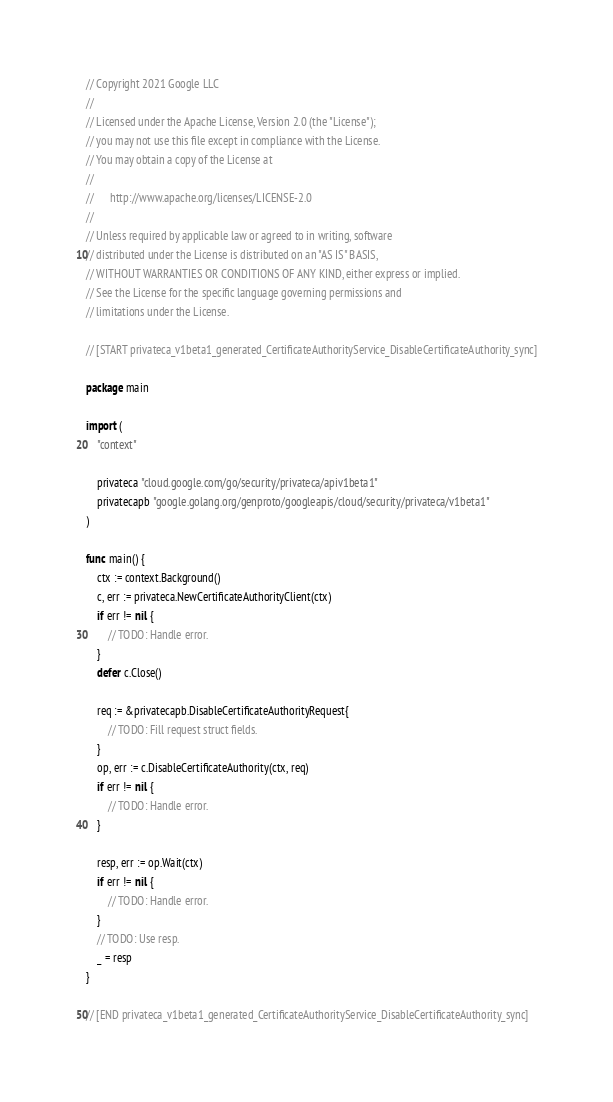<code> <loc_0><loc_0><loc_500><loc_500><_Go_>// Copyright 2021 Google LLC
//
// Licensed under the Apache License, Version 2.0 (the "License");
// you may not use this file except in compliance with the License.
// You may obtain a copy of the License at
//
//      http://www.apache.org/licenses/LICENSE-2.0
//
// Unless required by applicable law or agreed to in writing, software
// distributed under the License is distributed on an "AS IS" BASIS,
// WITHOUT WARRANTIES OR CONDITIONS OF ANY KIND, either express or implied.
// See the License for the specific language governing permissions and
// limitations under the License.

// [START privateca_v1beta1_generated_CertificateAuthorityService_DisableCertificateAuthority_sync]

package main

import (
	"context"

	privateca "cloud.google.com/go/security/privateca/apiv1beta1"
	privatecapb "google.golang.org/genproto/googleapis/cloud/security/privateca/v1beta1"
)

func main() {
	ctx := context.Background()
	c, err := privateca.NewCertificateAuthorityClient(ctx)
	if err != nil {
		// TODO: Handle error.
	}
	defer c.Close()

	req := &privatecapb.DisableCertificateAuthorityRequest{
		// TODO: Fill request struct fields.
	}
	op, err := c.DisableCertificateAuthority(ctx, req)
	if err != nil {
		// TODO: Handle error.
	}

	resp, err := op.Wait(ctx)
	if err != nil {
		// TODO: Handle error.
	}
	// TODO: Use resp.
	_ = resp
}

// [END privateca_v1beta1_generated_CertificateAuthorityService_DisableCertificateAuthority_sync]
</code> 